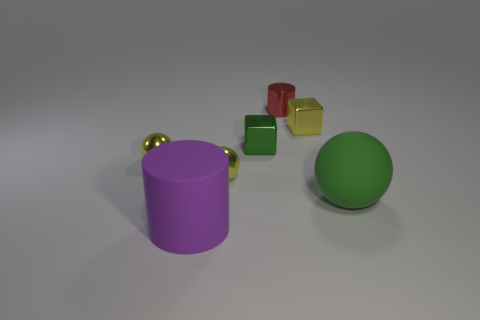Add 2 tiny yellow spheres. How many objects exist? 9 Subtract all spheres. How many objects are left? 4 Subtract 1 green blocks. How many objects are left? 6 Subtract all large gray metallic things. Subtract all green matte things. How many objects are left? 6 Add 7 metallic cubes. How many metallic cubes are left? 9 Add 4 tiny metallic cylinders. How many tiny metallic cylinders exist? 5 